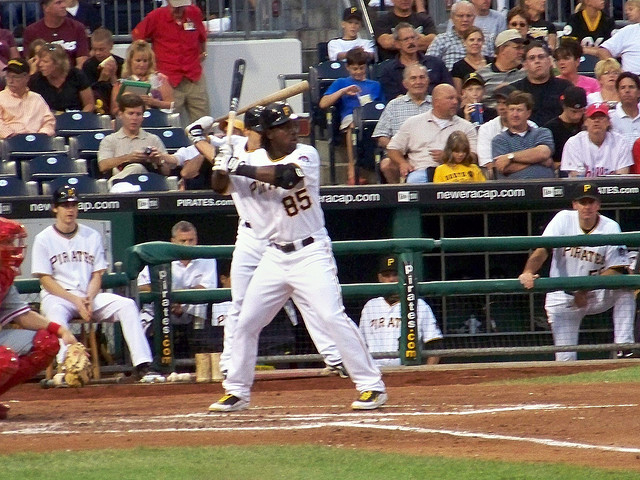Extract all visible text content from this image. 85 neweracap.com PIRATES pirates.com pirates.com PIRATES.com 